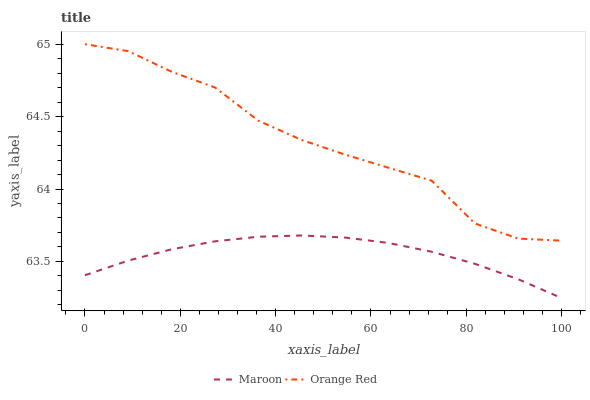Does Maroon have the minimum area under the curve?
Answer yes or no. Yes. Does Orange Red have the maximum area under the curve?
Answer yes or no. Yes. Does Maroon have the maximum area under the curve?
Answer yes or no. No. Is Maroon the smoothest?
Answer yes or no. Yes. Is Orange Red the roughest?
Answer yes or no. Yes. Is Maroon the roughest?
Answer yes or no. No. Does Maroon have the lowest value?
Answer yes or no. Yes. Does Orange Red have the highest value?
Answer yes or no. Yes. Does Maroon have the highest value?
Answer yes or no. No. Is Maroon less than Orange Red?
Answer yes or no. Yes. Is Orange Red greater than Maroon?
Answer yes or no. Yes. Does Maroon intersect Orange Red?
Answer yes or no. No. 